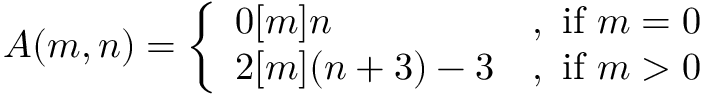Convert formula to latex. <formula><loc_0><loc_0><loc_500><loc_500>A ( m , n ) = { \left \{ \begin{array} { l l } { 0 [ m ] n } & { { , i f } m = 0 } \\ { 2 [ m ] ( n + 3 ) - 3 } & { { , i f } m > 0 } \end{array} }</formula> 